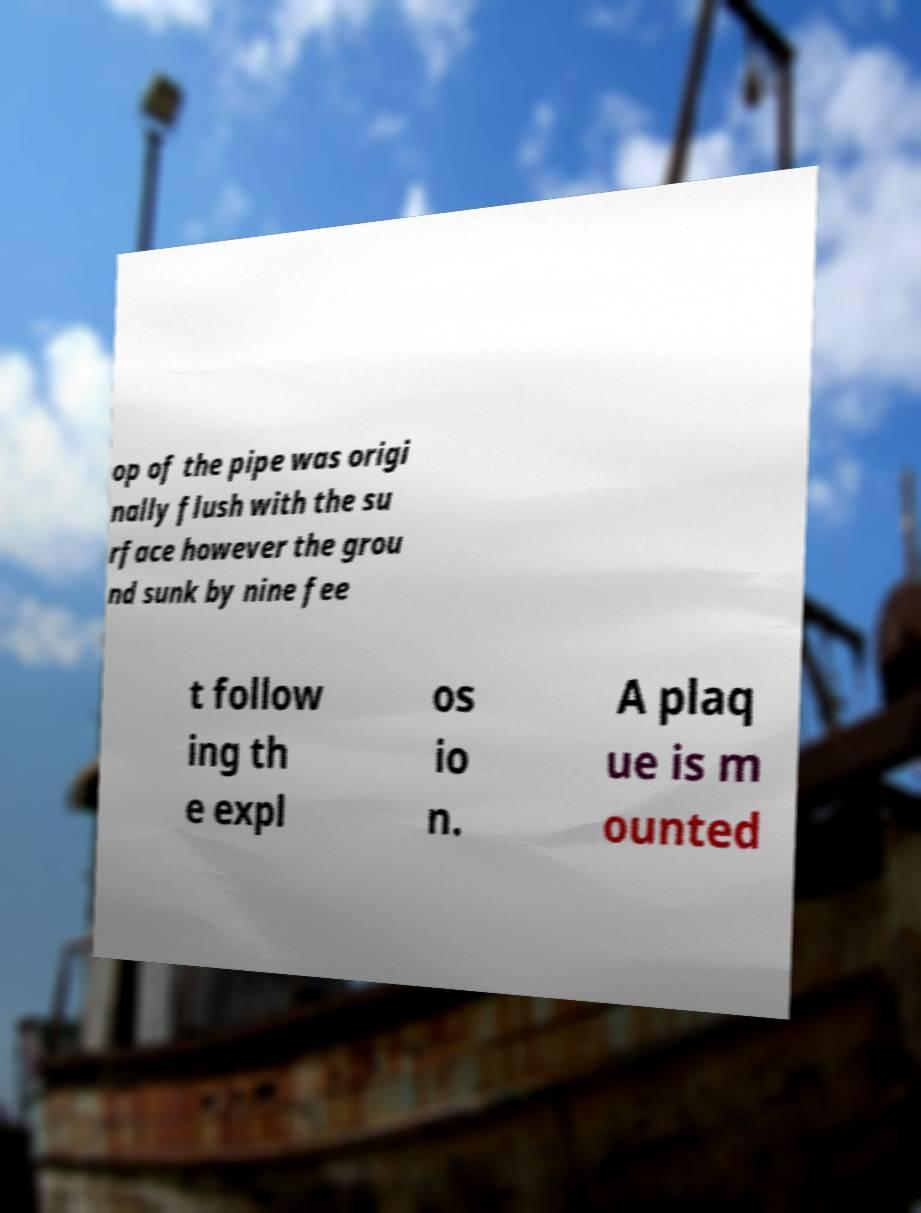Can you read and provide the text displayed in the image?This photo seems to have some interesting text. Can you extract and type it out for me? op of the pipe was origi nally flush with the su rface however the grou nd sunk by nine fee t follow ing th e expl os io n. A plaq ue is m ounted 